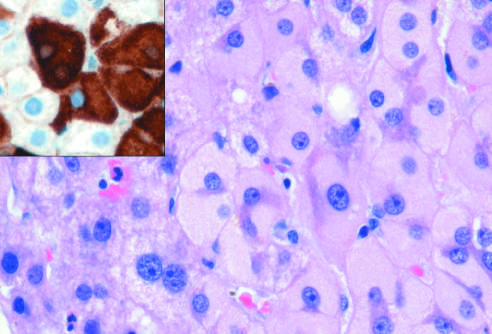what confirms the presence of surface antigen (brown)?
Answer the question using a single word or phrase. Immunostaining with a specific antibody 